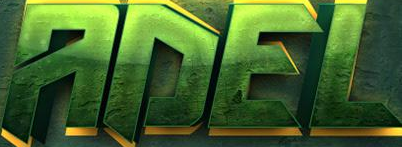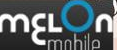What text appears in these images from left to right, separated by a semicolon? ADEL; mɛLon 